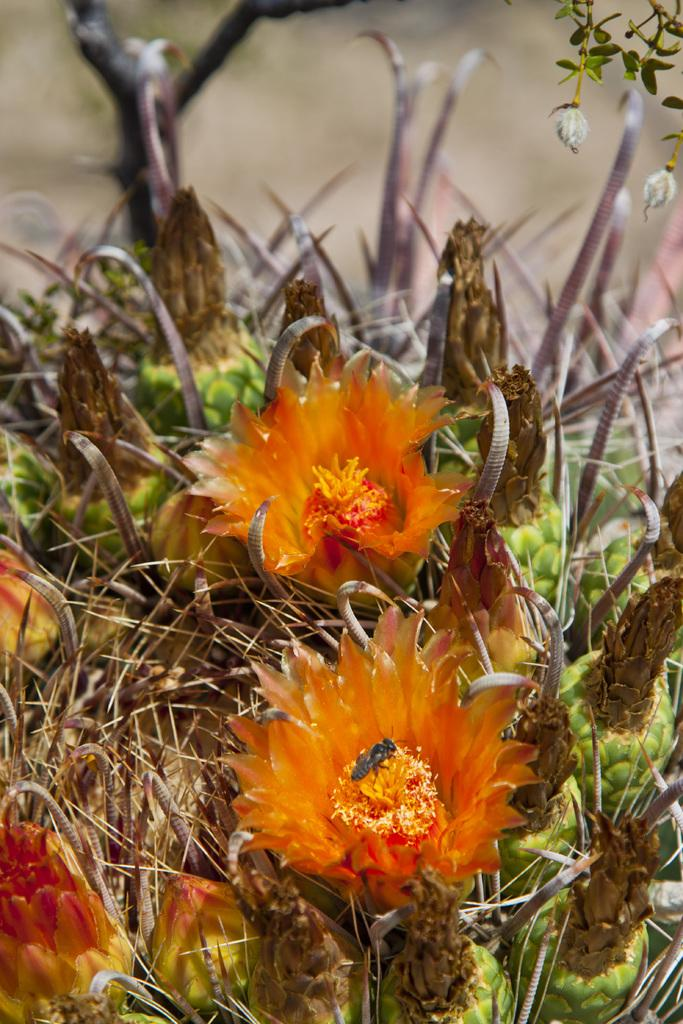What type of plant is in the image? There is a flower plant in the image. What can be seen on the flower plant? The flower plant has flowers. Can you describe the background of the image? The background of the image is blurry. What scientific discoveries are being made by the teeth in the image? There are no teeth present in the image, so no scientific discoveries can be made by them. 